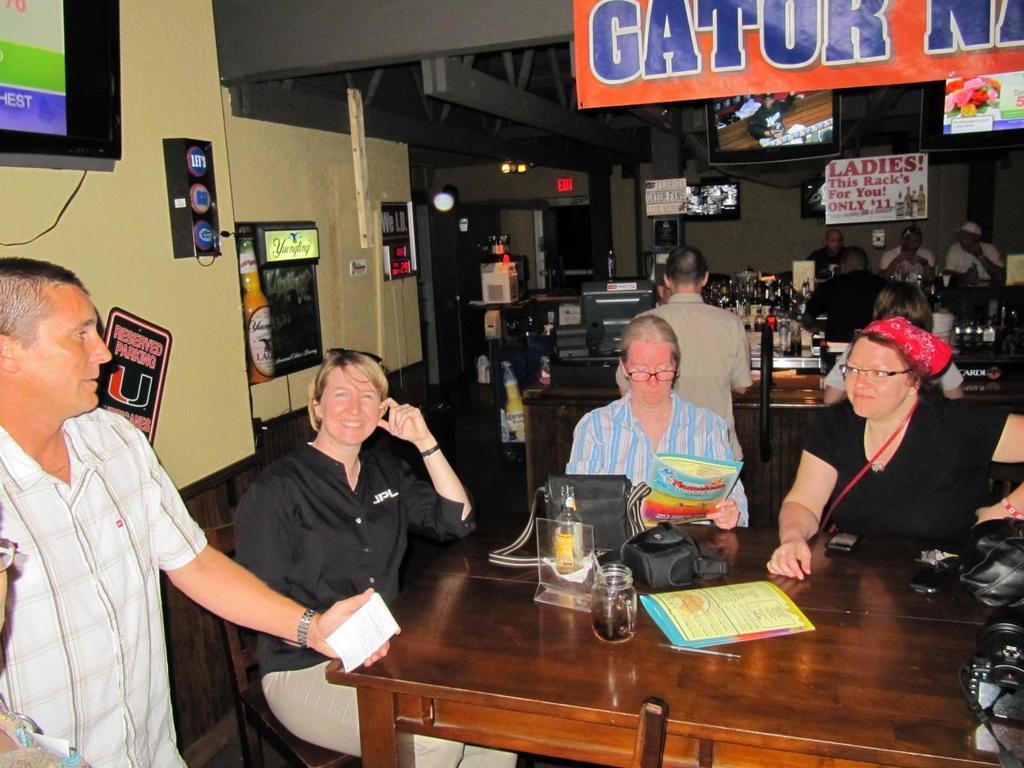Please provide a concise description of this image. An indoor picture. Televisions on wall. Persons are sitting on chair and few persons are standing. In-front of them there are tables, on this table there are bags, jar, camera, mobile, keys and card. This man is holding a paper. The woman in black shirt is smiling. Far there is a poster in-between of this televisions. In-front of this television there is a banner. Far there is a table, this table is filled with bottles. 